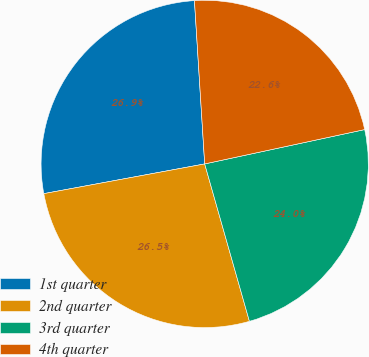Convert chart. <chart><loc_0><loc_0><loc_500><loc_500><pie_chart><fcel>1st quarter<fcel>2nd quarter<fcel>3rd quarter<fcel>4th quarter<nl><fcel>26.91%<fcel>26.5%<fcel>23.96%<fcel>22.63%<nl></chart> 